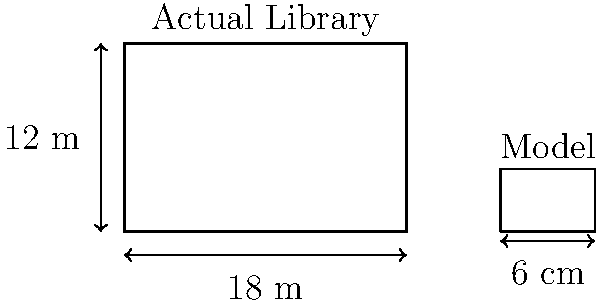As the school librarian, you're creating a miniature model of the library building for a school project. The actual library measures 18 meters in length and 12 meters in height. If the model's length is 6 cm, what is the scale of the model, and what should be the height of the model to maintain the correct proportions? Let's approach this step-by-step:

1. Calculate the scale of the model:
   - Actual length = 18 m = 1800 cm
   - Model length = 6 cm
   - Scale = Model length : Actual length
   - Scale = $6 : 1800 = 1 : 300$

2. To find the height of the model, we need to use the same scale:
   - Actual height = 12 m = 1200 cm
   - Let x be the model height in cm
   - Set up the proportion: $\frac{x}{1200} = \frac{1}{300}$

3. Solve for x:
   $x = \frac{1200}{300} = 4$ cm

Therefore, the scale of the model is 1:300, and the height of the model should be 4 cm to maintain the correct proportions.
Answer: Scale: 1:300; Model height: 4 cm 